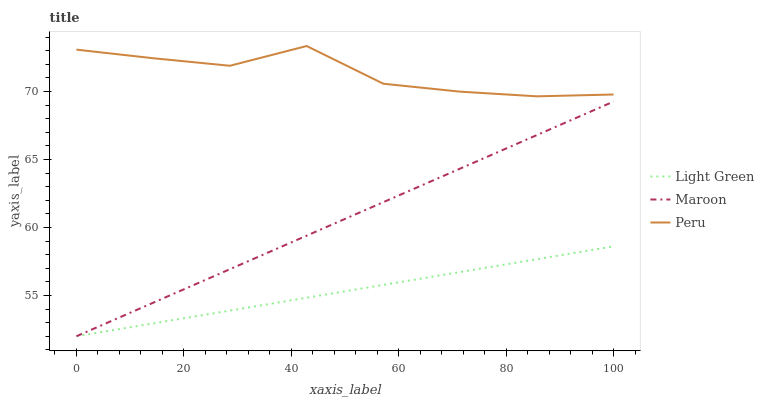Does Light Green have the minimum area under the curve?
Answer yes or no. Yes. Does Peru have the maximum area under the curve?
Answer yes or no. Yes. Does Maroon have the minimum area under the curve?
Answer yes or no. No. Does Maroon have the maximum area under the curve?
Answer yes or no. No. Is Light Green the smoothest?
Answer yes or no. Yes. Is Peru the roughest?
Answer yes or no. Yes. Is Maroon the smoothest?
Answer yes or no. No. Is Maroon the roughest?
Answer yes or no. No. Does Maroon have the lowest value?
Answer yes or no. Yes. Does Peru have the highest value?
Answer yes or no. Yes. Does Maroon have the highest value?
Answer yes or no. No. Is Maroon less than Peru?
Answer yes or no. Yes. Is Peru greater than Maroon?
Answer yes or no. Yes. Does Maroon intersect Light Green?
Answer yes or no. Yes. Is Maroon less than Light Green?
Answer yes or no. No. Is Maroon greater than Light Green?
Answer yes or no. No. Does Maroon intersect Peru?
Answer yes or no. No. 